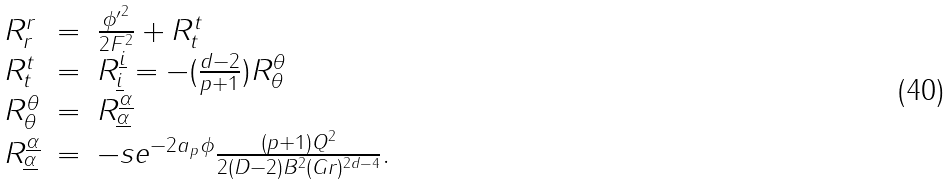<formula> <loc_0><loc_0><loc_500><loc_500>\begin{array} { l l l } R ^ { r } _ { r } & = & \frac { { \phi ^ { \prime } } ^ { 2 } } { 2 F ^ { 2 } } + R ^ { t } _ { t } \\ R ^ { t } _ { t } & = & R ^ { \underline { i } } _ { \underline { i } } = - ( \frac { d - 2 } { p + 1 } ) R ^ { \theta } _ { \theta } \\ R ^ { \theta } _ { \theta } & = & R ^ { \underline { \alpha } } _ { \underline { \alpha } } \\ R ^ { \underline { \alpha } } _ { \underline { \alpha } } & = & - s e ^ { - 2 a _ { p } \phi } \frac { ( p + 1 ) Q ^ { 2 } } { 2 ( D - 2 ) B ^ { 2 } ( G r ) ^ { 2 d - 4 } } . \end{array}</formula> 